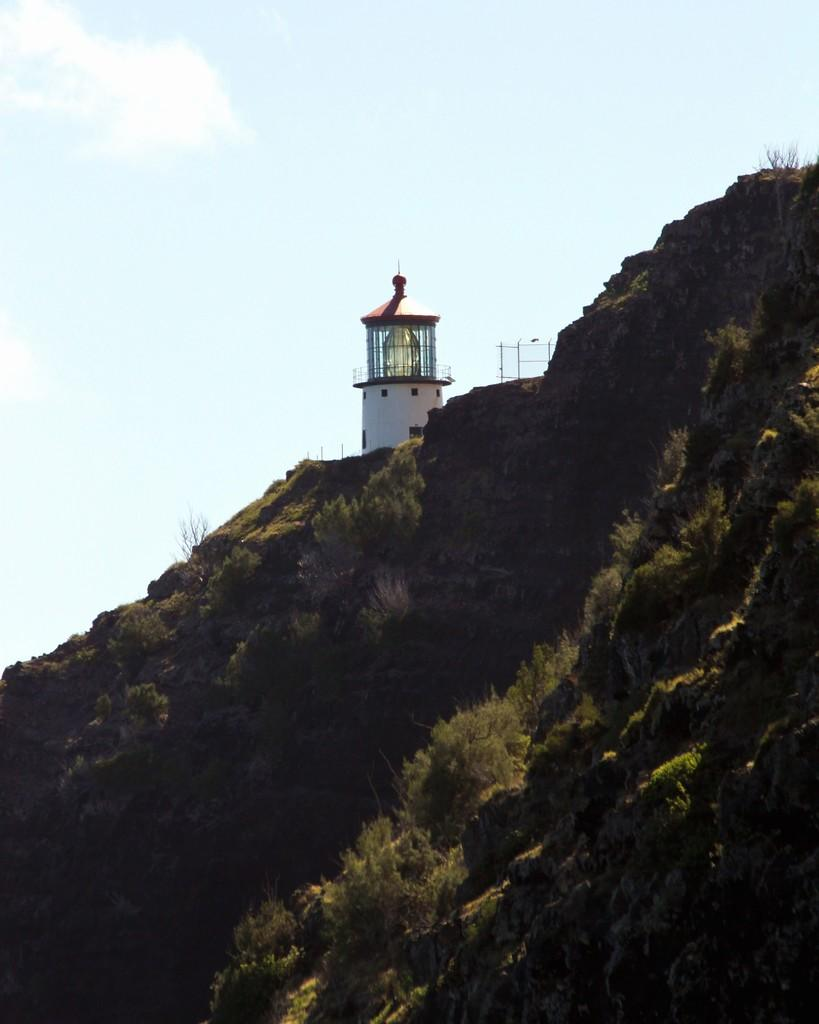What is the main structure in the image? There is a lighthouse in the image. Where is the lighthouse located? The lighthouse is on a mountain. What can be seen on the mountain besides the lighthouse? The mountain has rocks and grass. What is visible in the sky at the top of the image? There are clouds in the sky at the top of the image. What type of curtain can be seen hanging from the lighthouse in the image? There is no curtain present in the image; it features a lighthouse on a mountain with rocks and grass. What tool is being used to hammer the rocks on the mountain in the image? There is no hammer or hammering activity depicted in the image. 